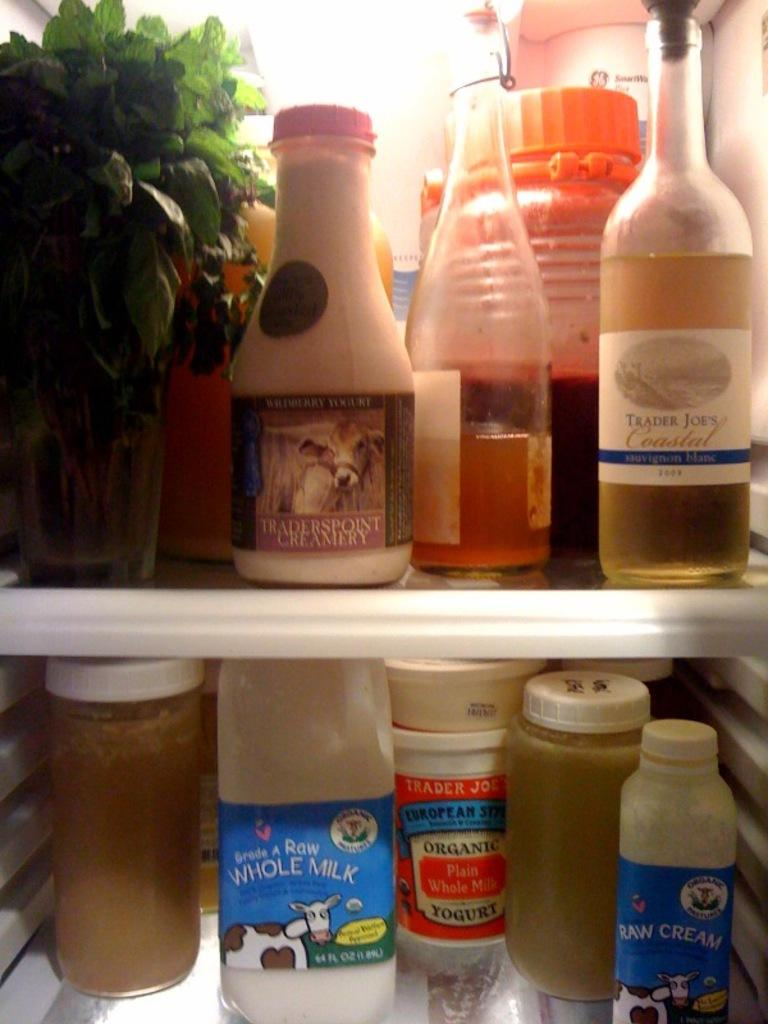<image>
Render a clear and concise summary of the photo. Plenty of stuff in the fridge, including a bottle of whole milk. 